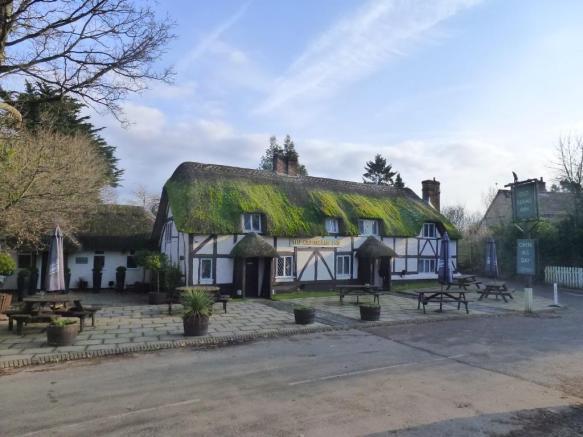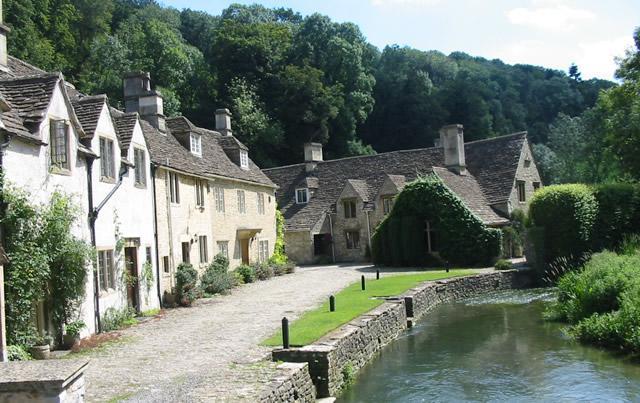The first image is the image on the left, the second image is the image on the right. Considering the images on both sides, is "A red chimney rises from a yellow building with a thatched roof." valid? Answer yes or no. No. The first image is the image on the left, the second image is the image on the right. For the images displayed, is the sentence "Each image shows a large building with a chimney sticking out of a non-shingle roof and multiple picnic tables situated near it." factually correct? Answer yes or no. No. 